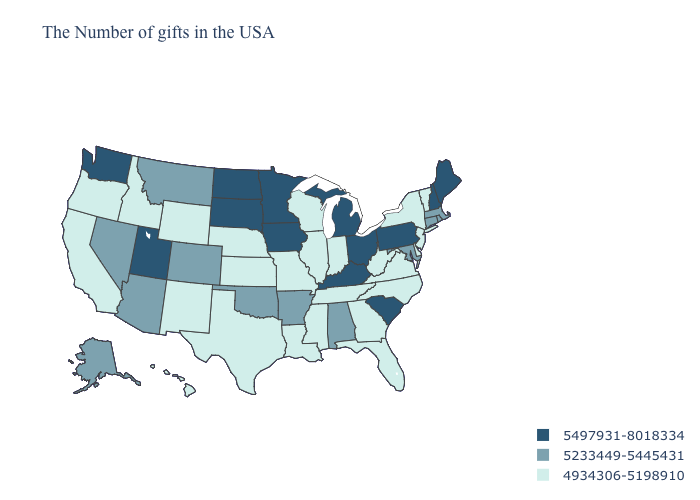What is the lowest value in the South?
Write a very short answer. 4934306-5198910. What is the value of Vermont?
Be succinct. 4934306-5198910. Name the states that have a value in the range 5233449-5445431?
Quick response, please. Massachusetts, Rhode Island, Connecticut, Maryland, Alabama, Arkansas, Oklahoma, Colorado, Montana, Arizona, Nevada, Alaska. Does Florida have the lowest value in the USA?
Be succinct. Yes. Name the states that have a value in the range 4934306-5198910?
Answer briefly. Vermont, New York, New Jersey, Delaware, Virginia, North Carolina, West Virginia, Florida, Georgia, Indiana, Tennessee, Wisconsin, Illinois, Mississippi, Louisiana, Missouri, Kansas, Nebraska, Texas, Wyoming, New Mexico, Idaho, California, Oregon, Hawaii. Does New Mexico have the same value as Mississippi?
Keep it brief. Yes. Which states have the highest value in the USA?
Give a very brief answer. Maine, New Hampshire, Pennsylvania, South Carolina, Ohio, Michigan, Kentucky, Minnesota, Iowa, South Dakota, North Dakota, Utah, Washington. What is the highest value in states that border Maine?
Write a very short answer. 5497931-8018334. What is the lowest value in the MidWest?
Short answer required. 4934306-5198910. What is the lowest value in states that border New Mexico?
Be succinct. 4934306-5198910. What is the value of New York?
Concise answer only. 4934306-5198910. What is the highest value in the West ?
Quick response, please. 5497931-8018334. Which states have the lowest value in the MidWest?
Be succinct. Indiana, Wisconsin, Illinois, Missouri, Kansas, Nebraska. Among the states that border Florida , which have the lowest value?
Quick response, please. Georgia. Which states have the highest value in the USA?
Concise answer only. Maine, New Hampshire, Pennsylvania, South Carolina, Ohio, Michigan, Kentucky, Minnesota, Iowa, South Dakota, North Dakota, Utah, Washington. 